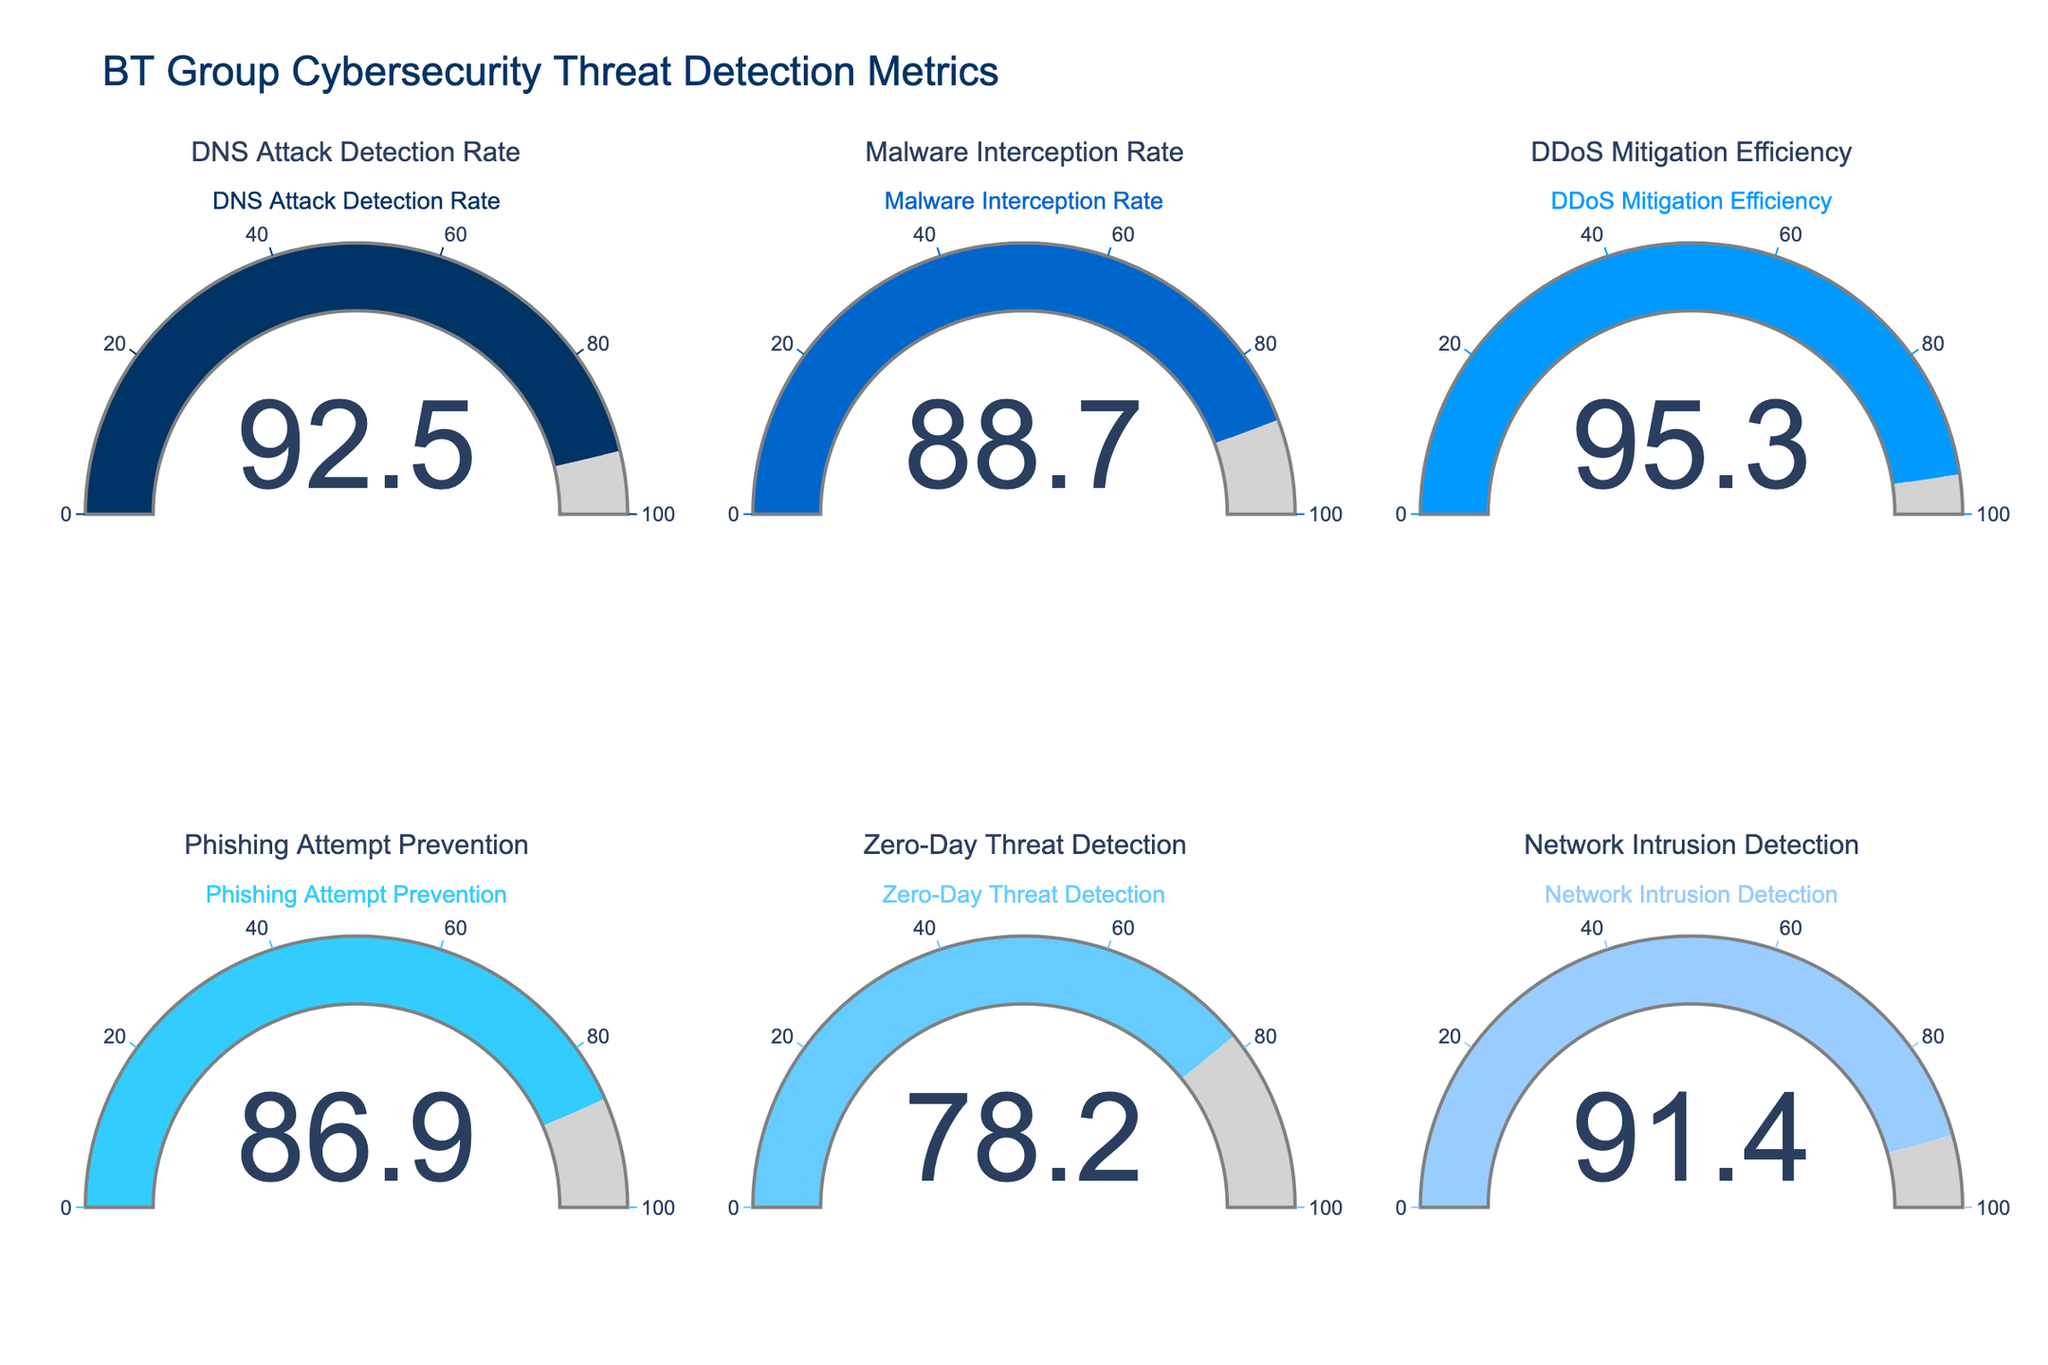Which cybersecurity threat has the highest detection rate? The gauge chart for each cybersecurity threat displays a numerical value. Comparing the values, the highest detection rate can be found for the "DDoS Mitigation Efficiency" with 95.3%.
Answer: DDoS Mitigation Efficiency What is the difference between the highest and lowest detection rates? The highest detection rate is for "DDoS Mitigation Efficiency" at 95.3%, and the lowest is for "Zero-Day Threat Detection" at 78.2%. Subtracting the lowest from the highest: 95.3 - 78.2 = 17.1.
Answer: 17.1 Which cybersecurity threat has the lowest detection rate? By reviewing the gauge charts, the lowest detection rate is visible in the "Zero-Day Threat Detection" metric with 78.2%.
Answer: Zero-Day Threat Detection What is the average detection rate across all metrics? Summing up all detection rates: 92.5 + 88.7 + 95.3 + 86.9 + 78.2 + 91.4 = 532.9. There are 6 metrics, so the average is 532.9 / 6 = 88.82.
Answer: 88.82 How many cybersecurity threats have a detection rate above 90%? By inspecting the individual gauges, the metrics with detection rates above 90% are "DNS Attack Detection Rate," "DDoS Mitigation Efficiency," and "Network Intrusion Detection," totaling 3.
Answer: 3 Which two metrics have the closest detection rates? Comparing the detection rates (92.5, 88.7, 95.3, 86.9, 78.2, 91.4), the closest two are "DNS Attack Detection Rate" (92.5) and "Network Intrusion Detection" (91.4), with a difference of 1.1.
Answer: DNS Attack Detection Rate and Network Intrusion Detection What color is used for the "Phishing Attempt Prevention" gauge? Observing the gauge charts, each metric has a distinct color. "Phishing Attempt Prevention" is in light blue.
Answer: Light blue What is the sum of the detection rates for DNS Attack Detection Rate and Malware Interception Rate? The detection rate for "DNS Attack Detection Rate" is 92.5, and for "Malware Interception Rate," it is 88.7. Summing these: 92.5 + 88.7 = 181.2.
Answer: 181.2 